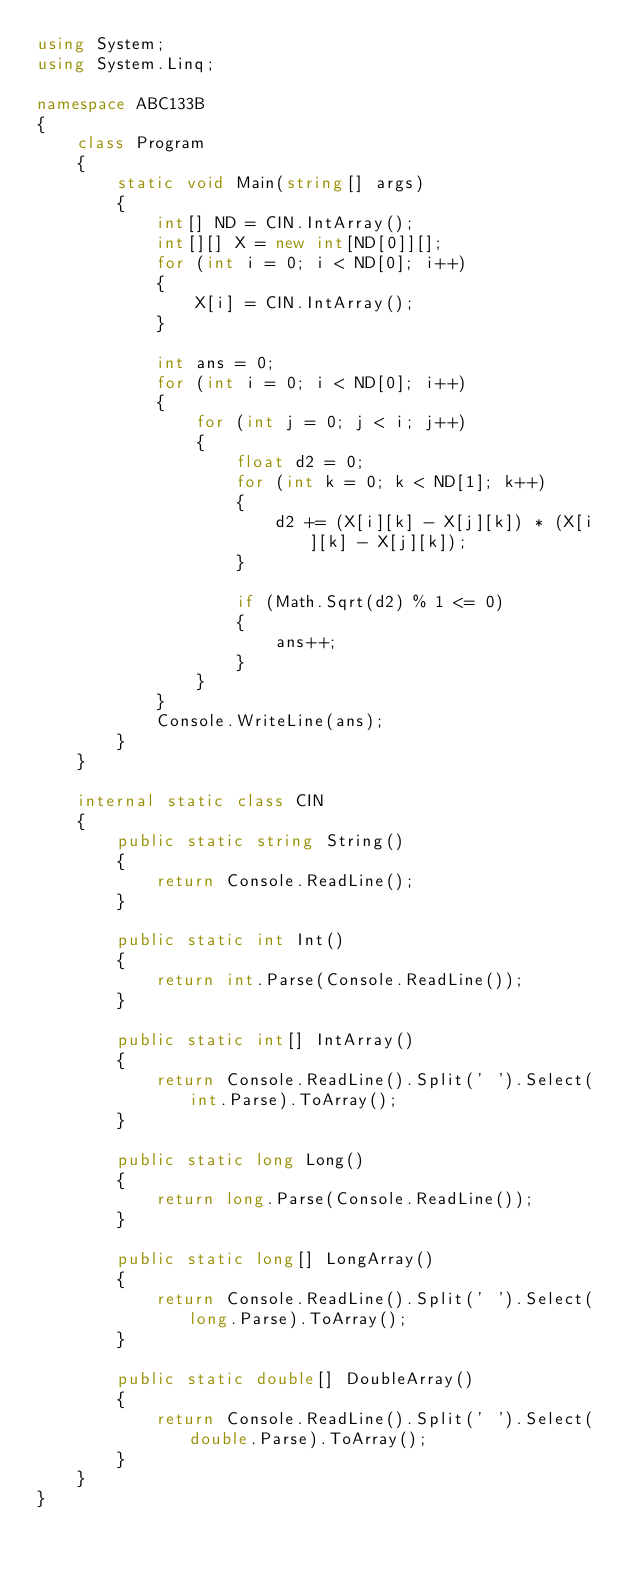<code> <loc_0><loc_0><loc_500><loc_500><_C#_>using System;
using System.Linq;

namespace ABC133B
{
    class Program
    {
        static void Main(string[] args)
        {
            int[] ND = CIN.IntArray();
            int[][] X = new int[ND[0]][];
            for (int i = 0; i < ND[0]; i++)
            {
                X[i] = CIN.IntArray();
            }

            int ans = 0;
            for (int i = 0; i < ND[0]; i++)
            {
                for (int j = 0; j < i; j++)
                {
                    float d2 = 0;
                    for (int k = 0; k < ND[1]; k++)
                    {
                        d2 += (X[i][k] - X[j][k]) * (X[i][k] - X[j][k]);
                    }

                    if (Math.Sqrt(d2) % 1 <= 0)
                    {
                        ans++;
                    }
                }
            }
            Console.WriteLine(ans);
        }
    }

    internal static class CIN
    {
        public static string String()
        {
            return Console.ReadLine();
        }

        public static int Int()
        {
            return int.Parse(Console.ReadLine());
        }

        public static int[] IntArray()
        {
            return Console.ReadLine().Split(' ').Select(int.Parse).ToArray();
        }

        public static long Long()
        {
            return long.Parse(Console.ReadLine());
        }

        public static long[] LongArray()
        {
            return Console.ReadLine().Split(' ').Select(long.Parse).ToArray();
        }

        public static double[] DoubleArray()
        {
            return Console.ReadLine().Split(' ').Select(double.Parse).ToArray();
        }
    }
}</code> 